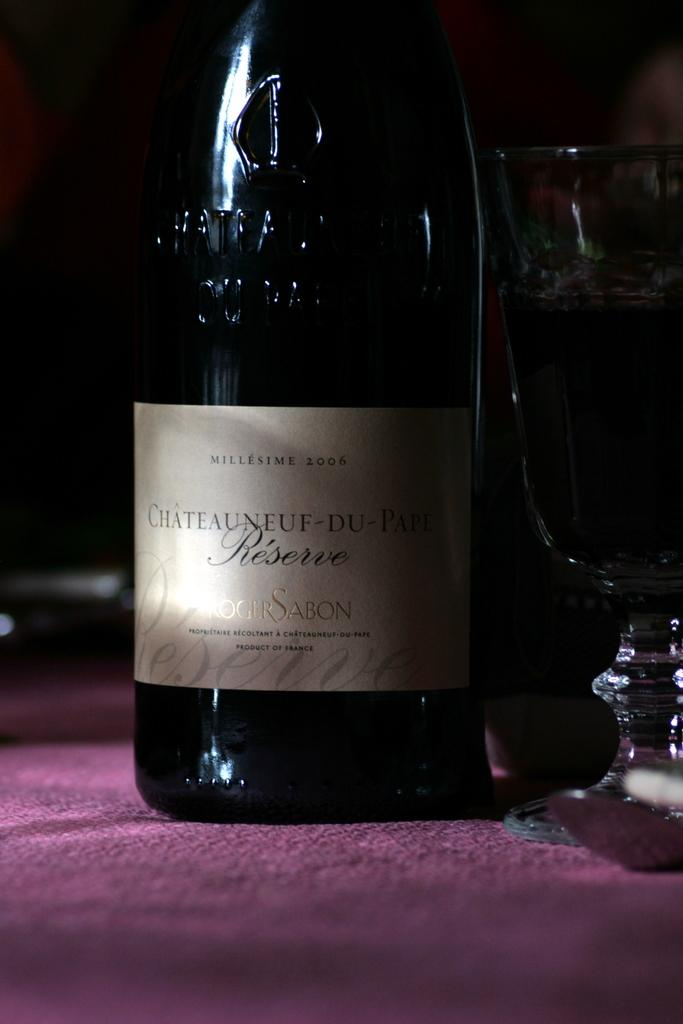<image>
Summarize the visual content of the image. A bottle of wine says that is it from the year 2006. 